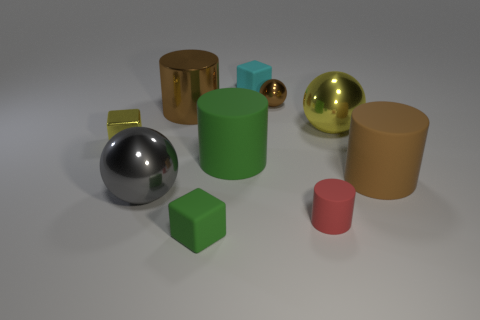Subtract 1 cylinders. How many cylinders are left? 3 Subtract all gray cylinders. Subtract all purple spheres. How many cylinders are left? 4 Subtract all cylinders. How many objects are left? 6 Subtract 1 yellow balls. How many objects are left? 9 Subtract all gray balls. Subtract all brown cylinders. How many objects are left? 7 Add 6 brown metal objects. How many brown metal objects are left? 8 Add 7 tiny rubber objects. How many tiny rubber objects exist? 10 